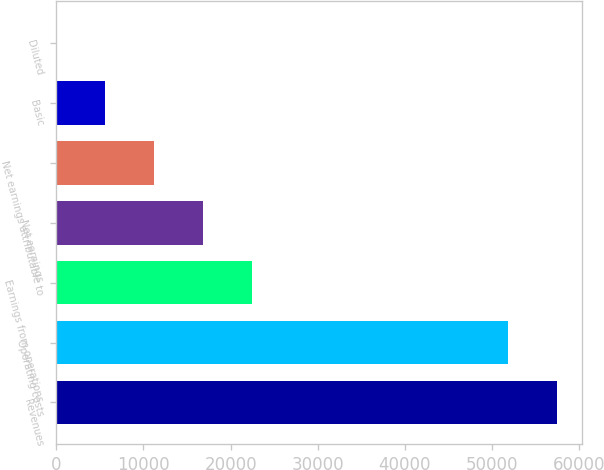Convert chart to OTSL. <chart><loc_0><loc_0><loc_500><loc_500><bar_chart><fcel>Revenues<fcel>Operating costs<fcel>Earnings from operations<fcel>Net earnings<fcel>Net earnings attributable to<fcel>Basic<fcel>Diluted<nl><fcel>57490.3<fcel>51882<fcel>22436.2<fcel>16827.9<fcel>11219.6<fcel>5611.28<fcel>2.98<nl></chart> 